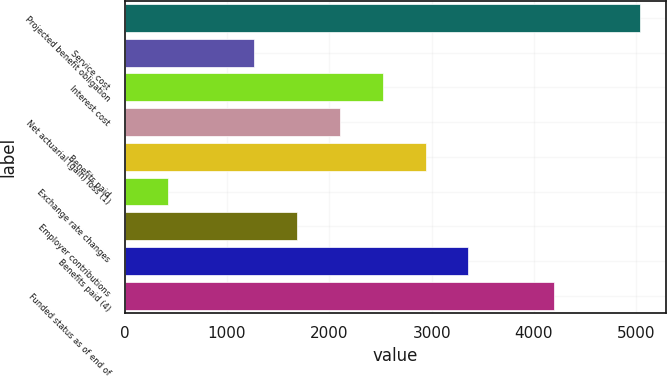<chart> <loc_0><loc_0><loc_500><loc_500><bar_chart><fcel>Projected benefit obligation<fcel>Service cost<fcel>Interest cost<fcel>Net actuarial (gain) loss (1)<fcel>Benefits paid<fcel>Exchange rate changes<fcel>Employer contributions<fcel>Benefits paid (4)<fcel>Funded status as of end of<nl><fcel>5038.2<fcel>1261.8<fcel>2520.6<fcel>2101<fcel>2940.2<fcel>422.6<fcel>1681.4<fcel>3359.8<fcel>4199<nl></chart> 